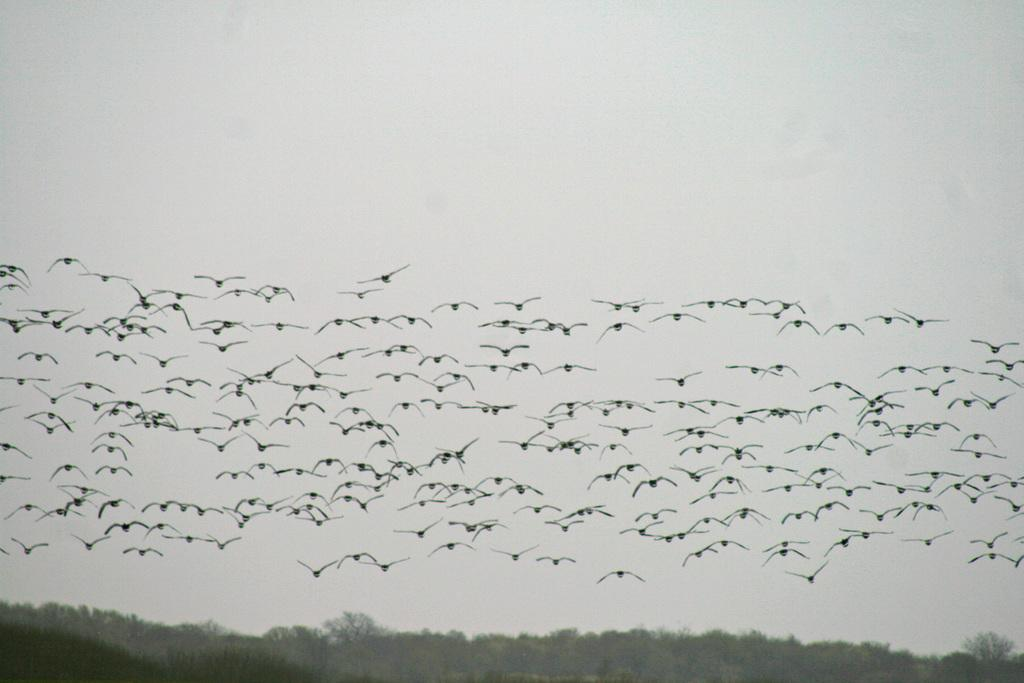What type of animals can be seen in the image? There are birds in the image. What are the birds doing in the image? The birds are flying in the sky. What can be seen at the bottom of the image? There are trees at the bottom of the image. Reasoning: Let'ing: Let's think step by step in order to produce the conversation. We start by identifying the main subject in the image, which is the birds. Then, we describe their action, which is flying in the sky. Finally, we mention the presence of trees at the bottom of the image. Each question is designed to elicit a specific detail about the image that is known from the provided facts. Absurd Question/Answer: What type of locket is hanging from the tree in the image? There is no locket present in the image; it only features birds flying in the sky and trees at the bottom. 